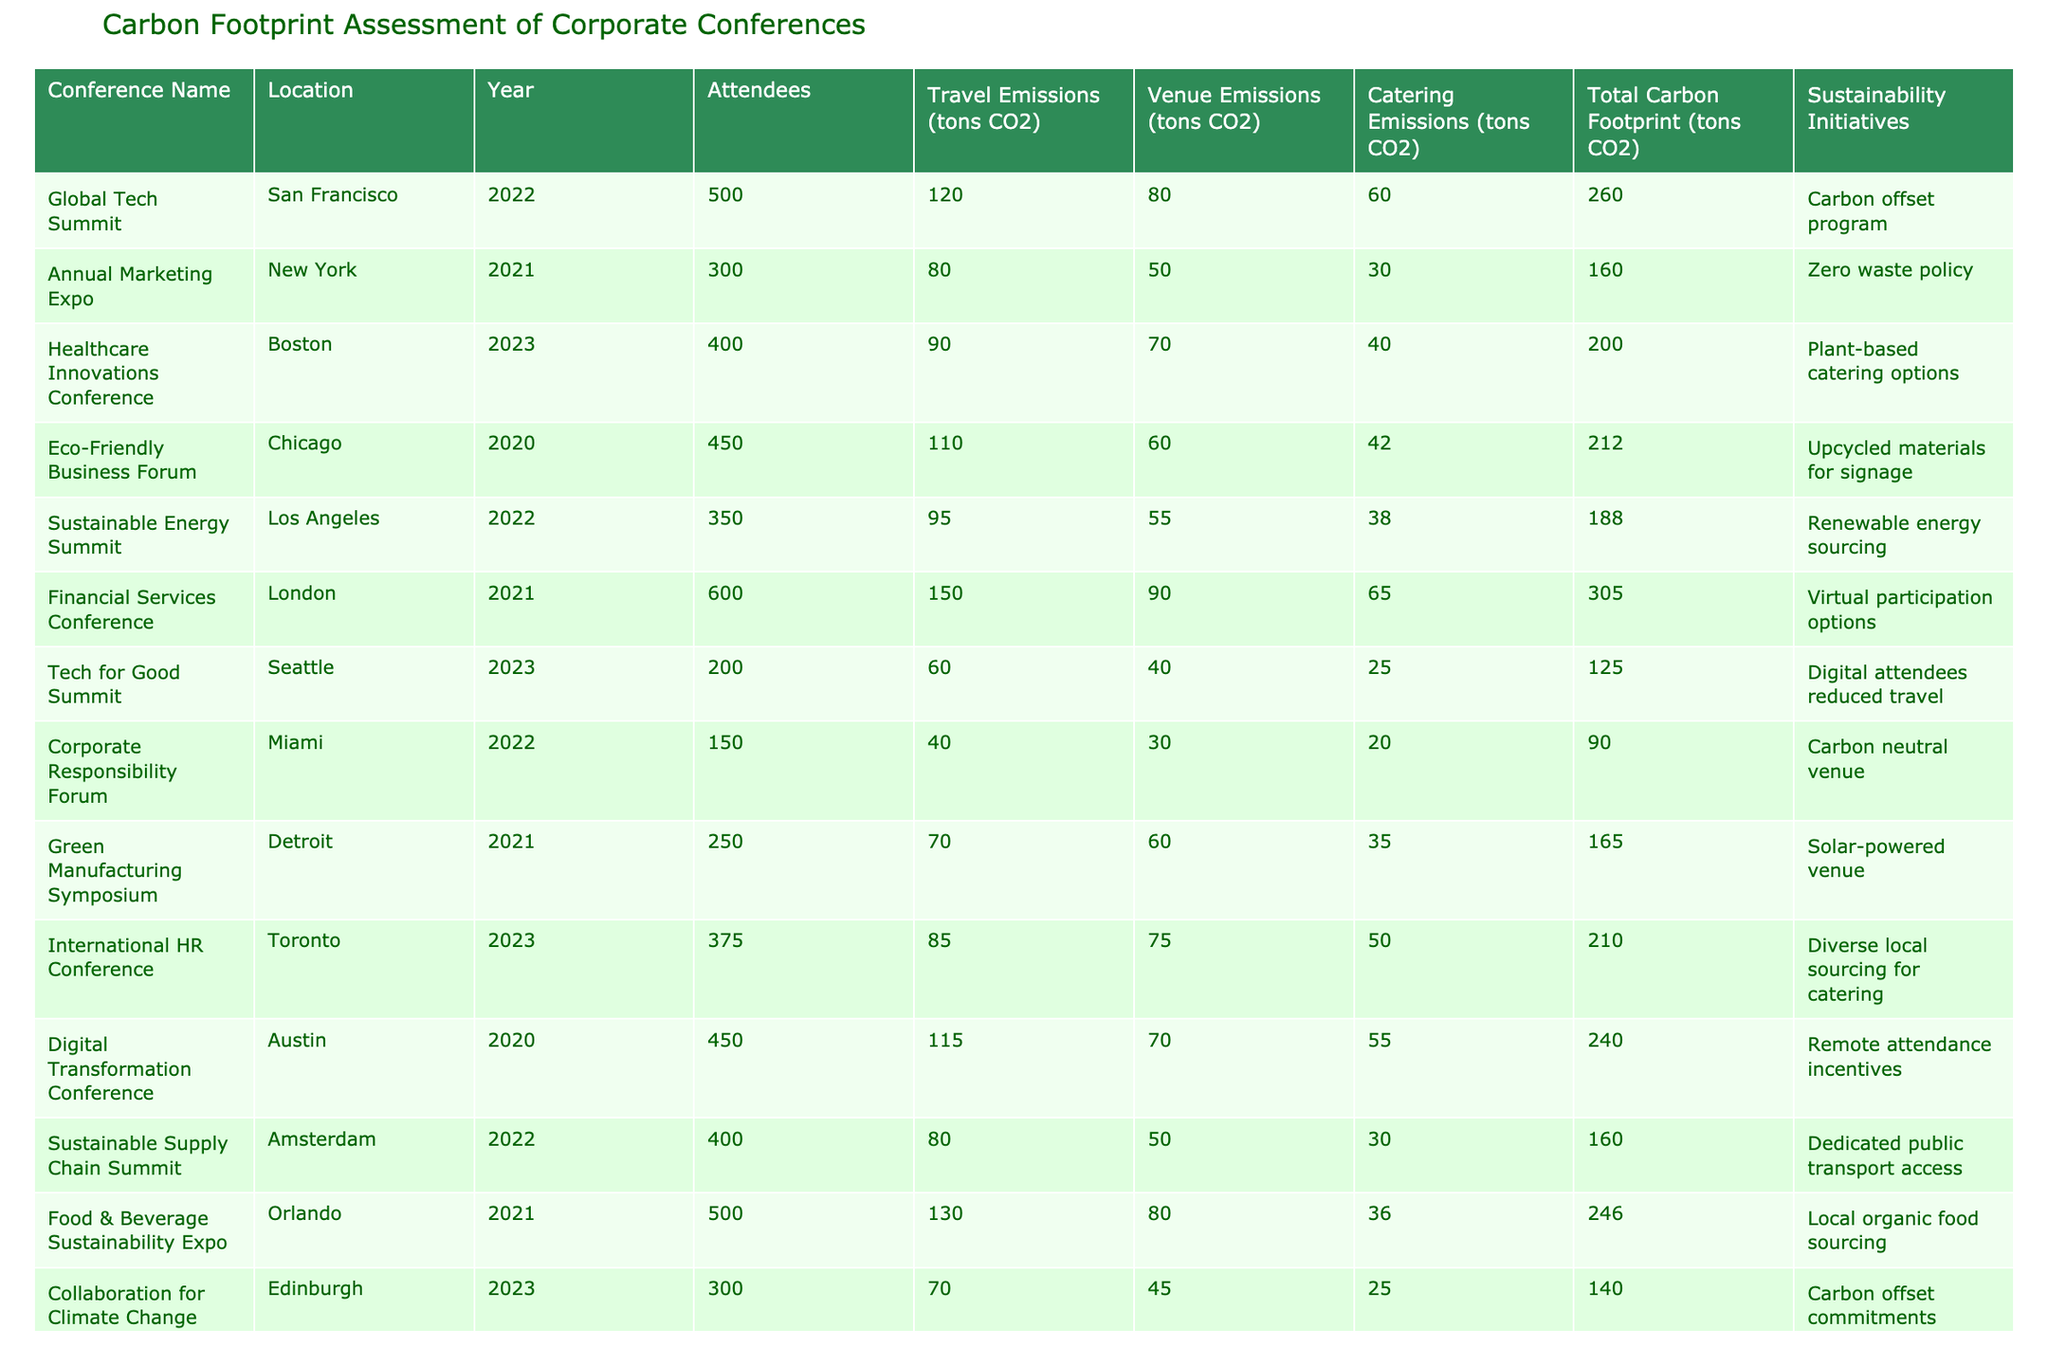What was the total carbon footprint of the Financial Services Conference? The total carbon footprint for the Financial Services Conference is listed in the table under the "Total Carbon Footprint" column, which shows a value of 305 tons CO2.
Answer: 305 tons CO2 Which conference had the highest travel emissions? By comparing the "Travel Emissions" column, the Financial Services Conference has the highest value at 150 tons CO2.
Answer: Financial Services Conference What is the average total carbon footprint of conferences held in 2022? The total carbon footprints for 2022 conferences are: 260 (Global Tech Summit), 188 (Sustainable Energy Summit), and 90 (Corporate Responsibility Forum), summing to 538 tons. Divided by 3 gives an average of 179.33 tons CO2.
Answer: 179.33 tons CO2 Is there a conference that implemented a zero waste policy? Looking at the "Sustainability Initiatives" column, the Annual Marketing Expo lists a zero waste policy implemented during the conference.
Answer: Yes Which location had a conference with the least total carbon footprint? By examining the "Total Carbon Footprint" column, the Corporate Responsibility Forum in Miami has the least amount at 90 tons CO2.
Answer: Miami How much do the catering emissions of the Healthcare Innovations Conference contribute relative to its total carbon footprint? The catering emissions are 40 tons CO2, while the total carbon footprint is 200 tons CO2, so the proportion is (40/200) * 100 = 20%.
Answer: 20% Which conference had more attendees: Digital Transformation Conference or Eco-Friendly Business Forum? The Digital Transformation Conference had 450 attendees, while the Eco-Friendly Business Forum had 450. Both have the same attendee count.
Answer: Both had 450 attendees What is the total carbon footprint of conferences with plant-based catering options? The only conference with plant-based catering options is the Healthcare Innovations Conference, which has a total footprint of 200 tons CO2.
Answer: 200 tons CO2 Are there more conferences with travel emissions over 100 tons CO2 than those with under 100 tons CO2? There are four conferences with travel emissions exceeding 100 tons CO2 (Global Tech Summit, Financial Services Conference, Food & Beverage Sustainability Expo, and Digital Transformation Conference), while five have emissions under 100 tons CO2. Thus, there are fewer conferences with over 100 tons CO2.
Answer: No If a new conference were to be organized with 400 attendees, and they emitted an average of 45 tons CO2 each from travel, what would their total travel emissions be? If each of the 400 attendees were to generate an average of 45 tons CO2, then the total would be 400 * 45 = 18,000 tons CO2 for travel emissions.
Answer: 18,000 tons CO2 